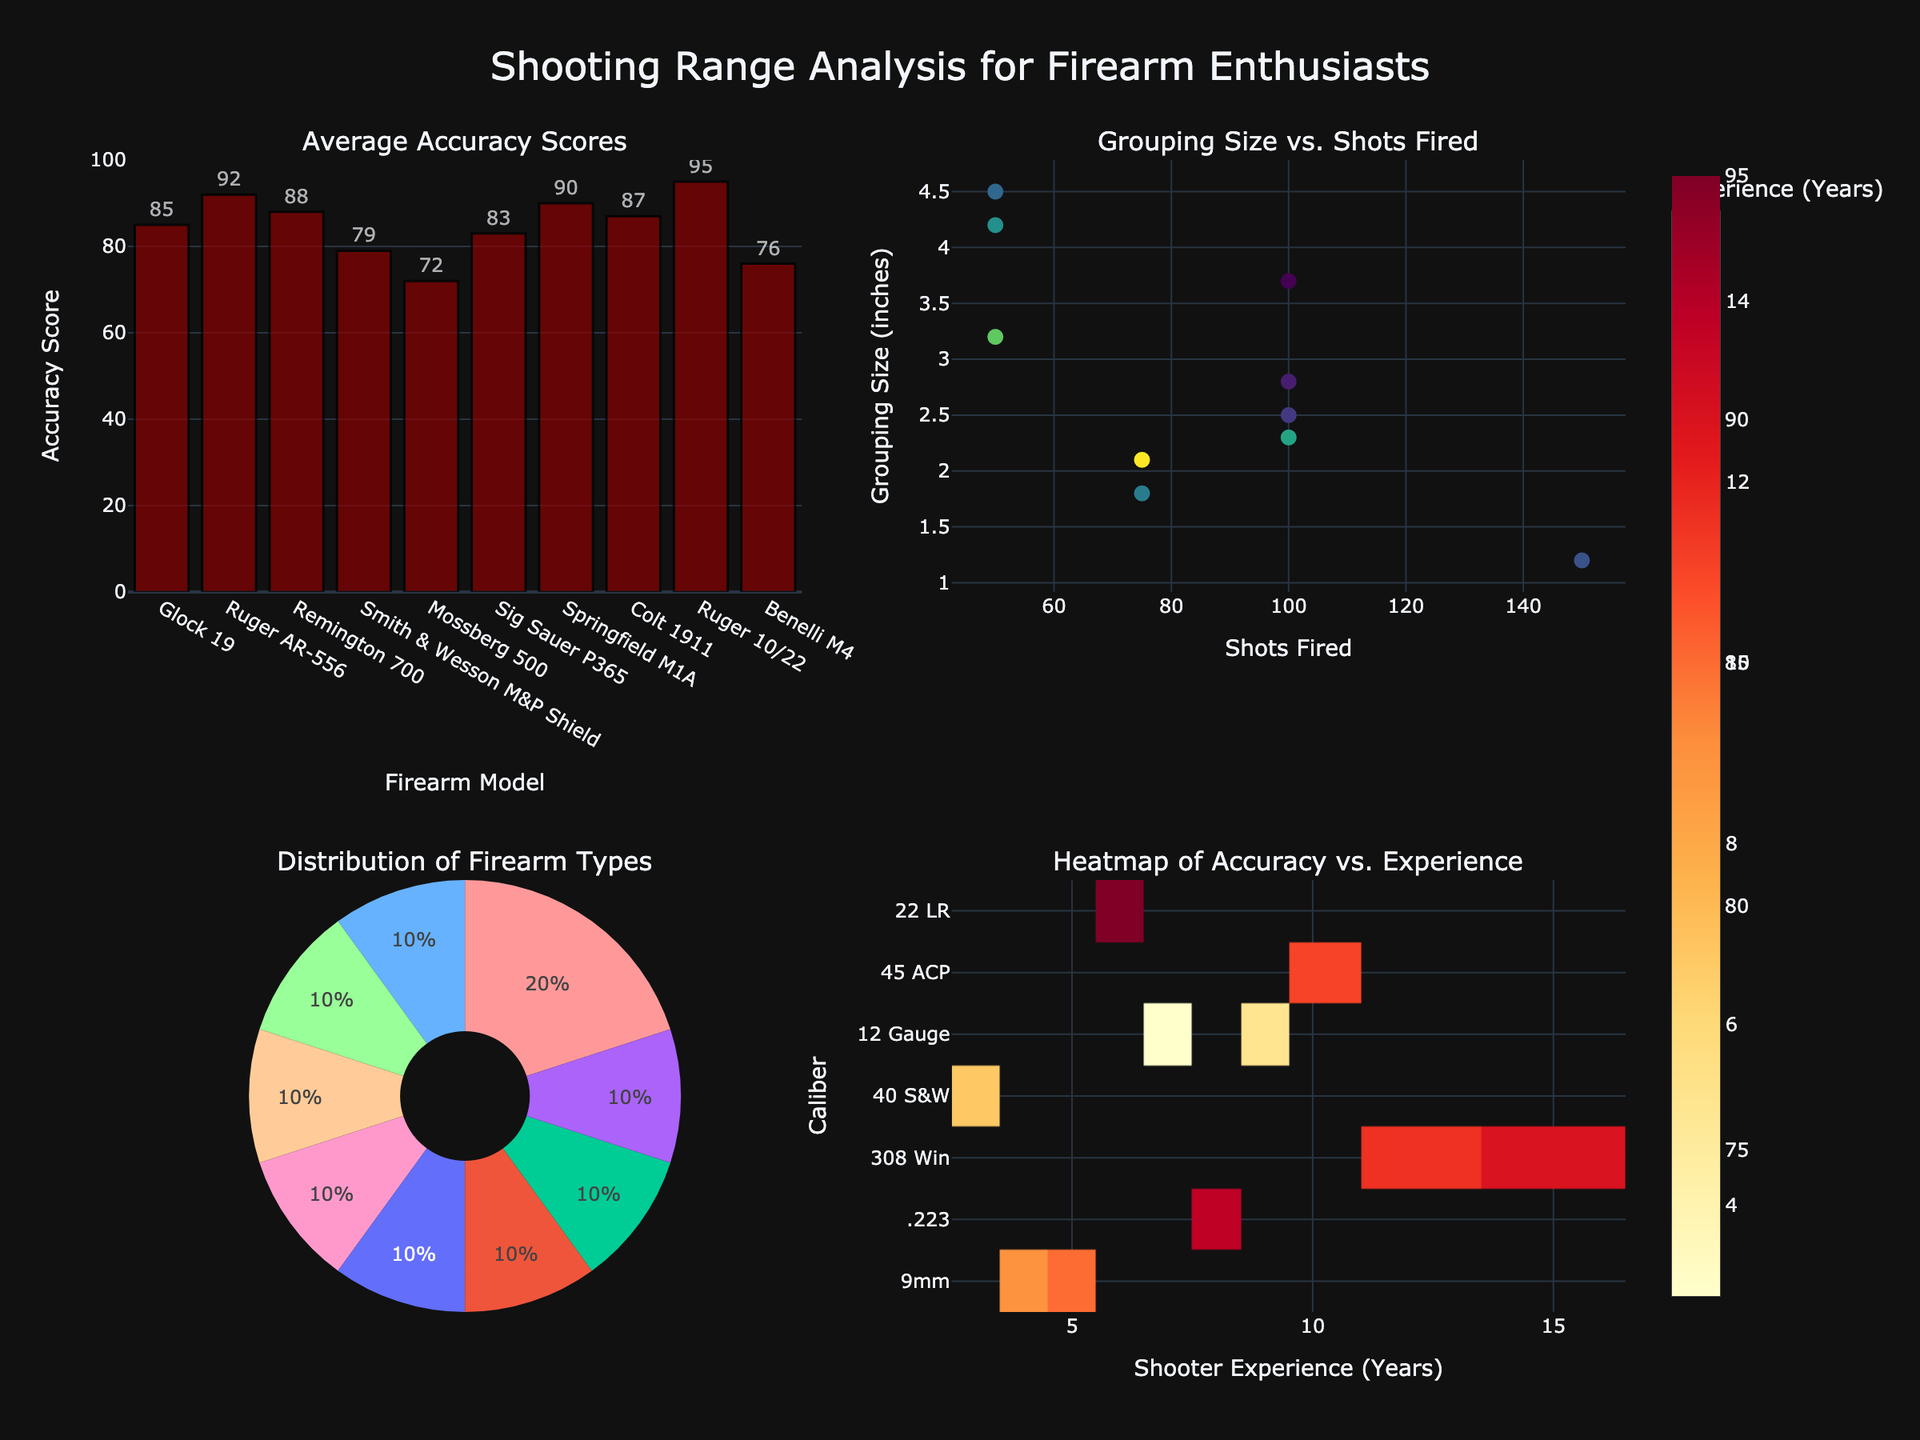What is the title of the figure? The title of the figure is displayed prominently at the top-center and reads "Impact of Charitable Event Sponsorship on Brand Loyalty".
Answer: Impact of Charitable Event Sponsorship on Brand Loyalty How many subplots does the figure contain? The figure contains four distinct subplots, arranged in a 2x2 grid layout. Each has a separate title.
Answer: Four Which brand shows the highest retention rate? Observing the second subplot, we see a sorted bar chart of retention rates by brand. The brand with the highest bar and retention rate is Disney.
Answer: Disney Did any brands show no change in loyalty before and after the events? In the first subplot, if any point lies on the 'No Change Line,' it signifies no difference in loyalty before and after the event. Based on the scatter points, no brands lie exactly on this line, indicating all brands saw some change.
Answer: None What was the average loyalty increase for the year 2020? The third subplot displays a line plot of average loyalty increase by year. For 2020, the corresponding point on the line graph indicates an average loyalty increase of approximately 5.
Answer: Approximately 5 Which event had the highest loyalty after? In the fourth subplot, which features a box plot labeled "Event Impact on Loyalty," the Make-A-Wish Foundation Gala shows the highest average loyalty after the event, as it has the highest upper whisker.
Answer: Make-A-Wish Foundation Gala How does the average loyalty increase in 2019 compare to 2021? By comparing the points in the third subplot, 2019 has a lower average loyalty increase than 2021. The point for 2021 is higher on the y-axis than the one for 2019.
Answer: 2021 has a higher average loyalty increase Which subplot shows the relationship between loyalty before and after the events? The first subplot, titled "Brand Loyalty Before vs After," uses a scatter plot to illustrate the relationship between loyalty before and after the events.
Answer: First subplot What is the retention rate for Walmart? From the second subplot, which lists brands and their retention rates, Walmart's bar is at 77%.
Answer: 77% How does the loyalty change for Nike compare to Home Depot before and after their respective events? Referring to the first subplot, Nike's loyalty increased from 72 to 78, a difference of 6. Home Depot's loyalty increased from 65 to 71, a difference of 6. Both brands show an equal increase in loyalty.
Answer: Equal increase (6) 